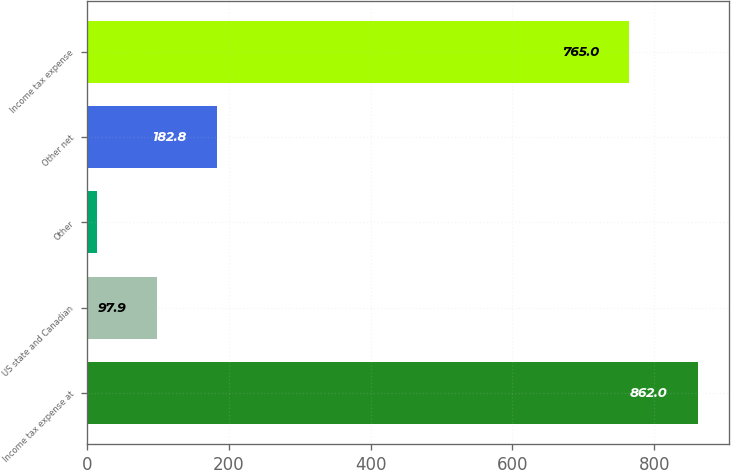<chart> <loc_0><loc_0><loc_500><loc_500><bar_chart><fcel>Income tax expense at<fcel>US state and Canadian<fcel>Other<fcel>Other net<fcel>Income tax expense<nl><fcel>862<fcel>97.9<fcel>13<fcel>182.8<fcel>765<nl></chart> 